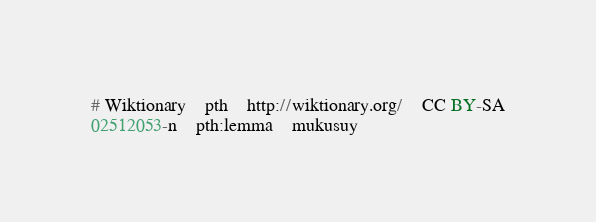<code> <loc_0><loc_0><loc_500><loc_500><_SQL_># Wiktionary	pth	http://wiktionary.org/	CC BY-SA
02512053-n	pth:lemma	mukusuy
</code> 